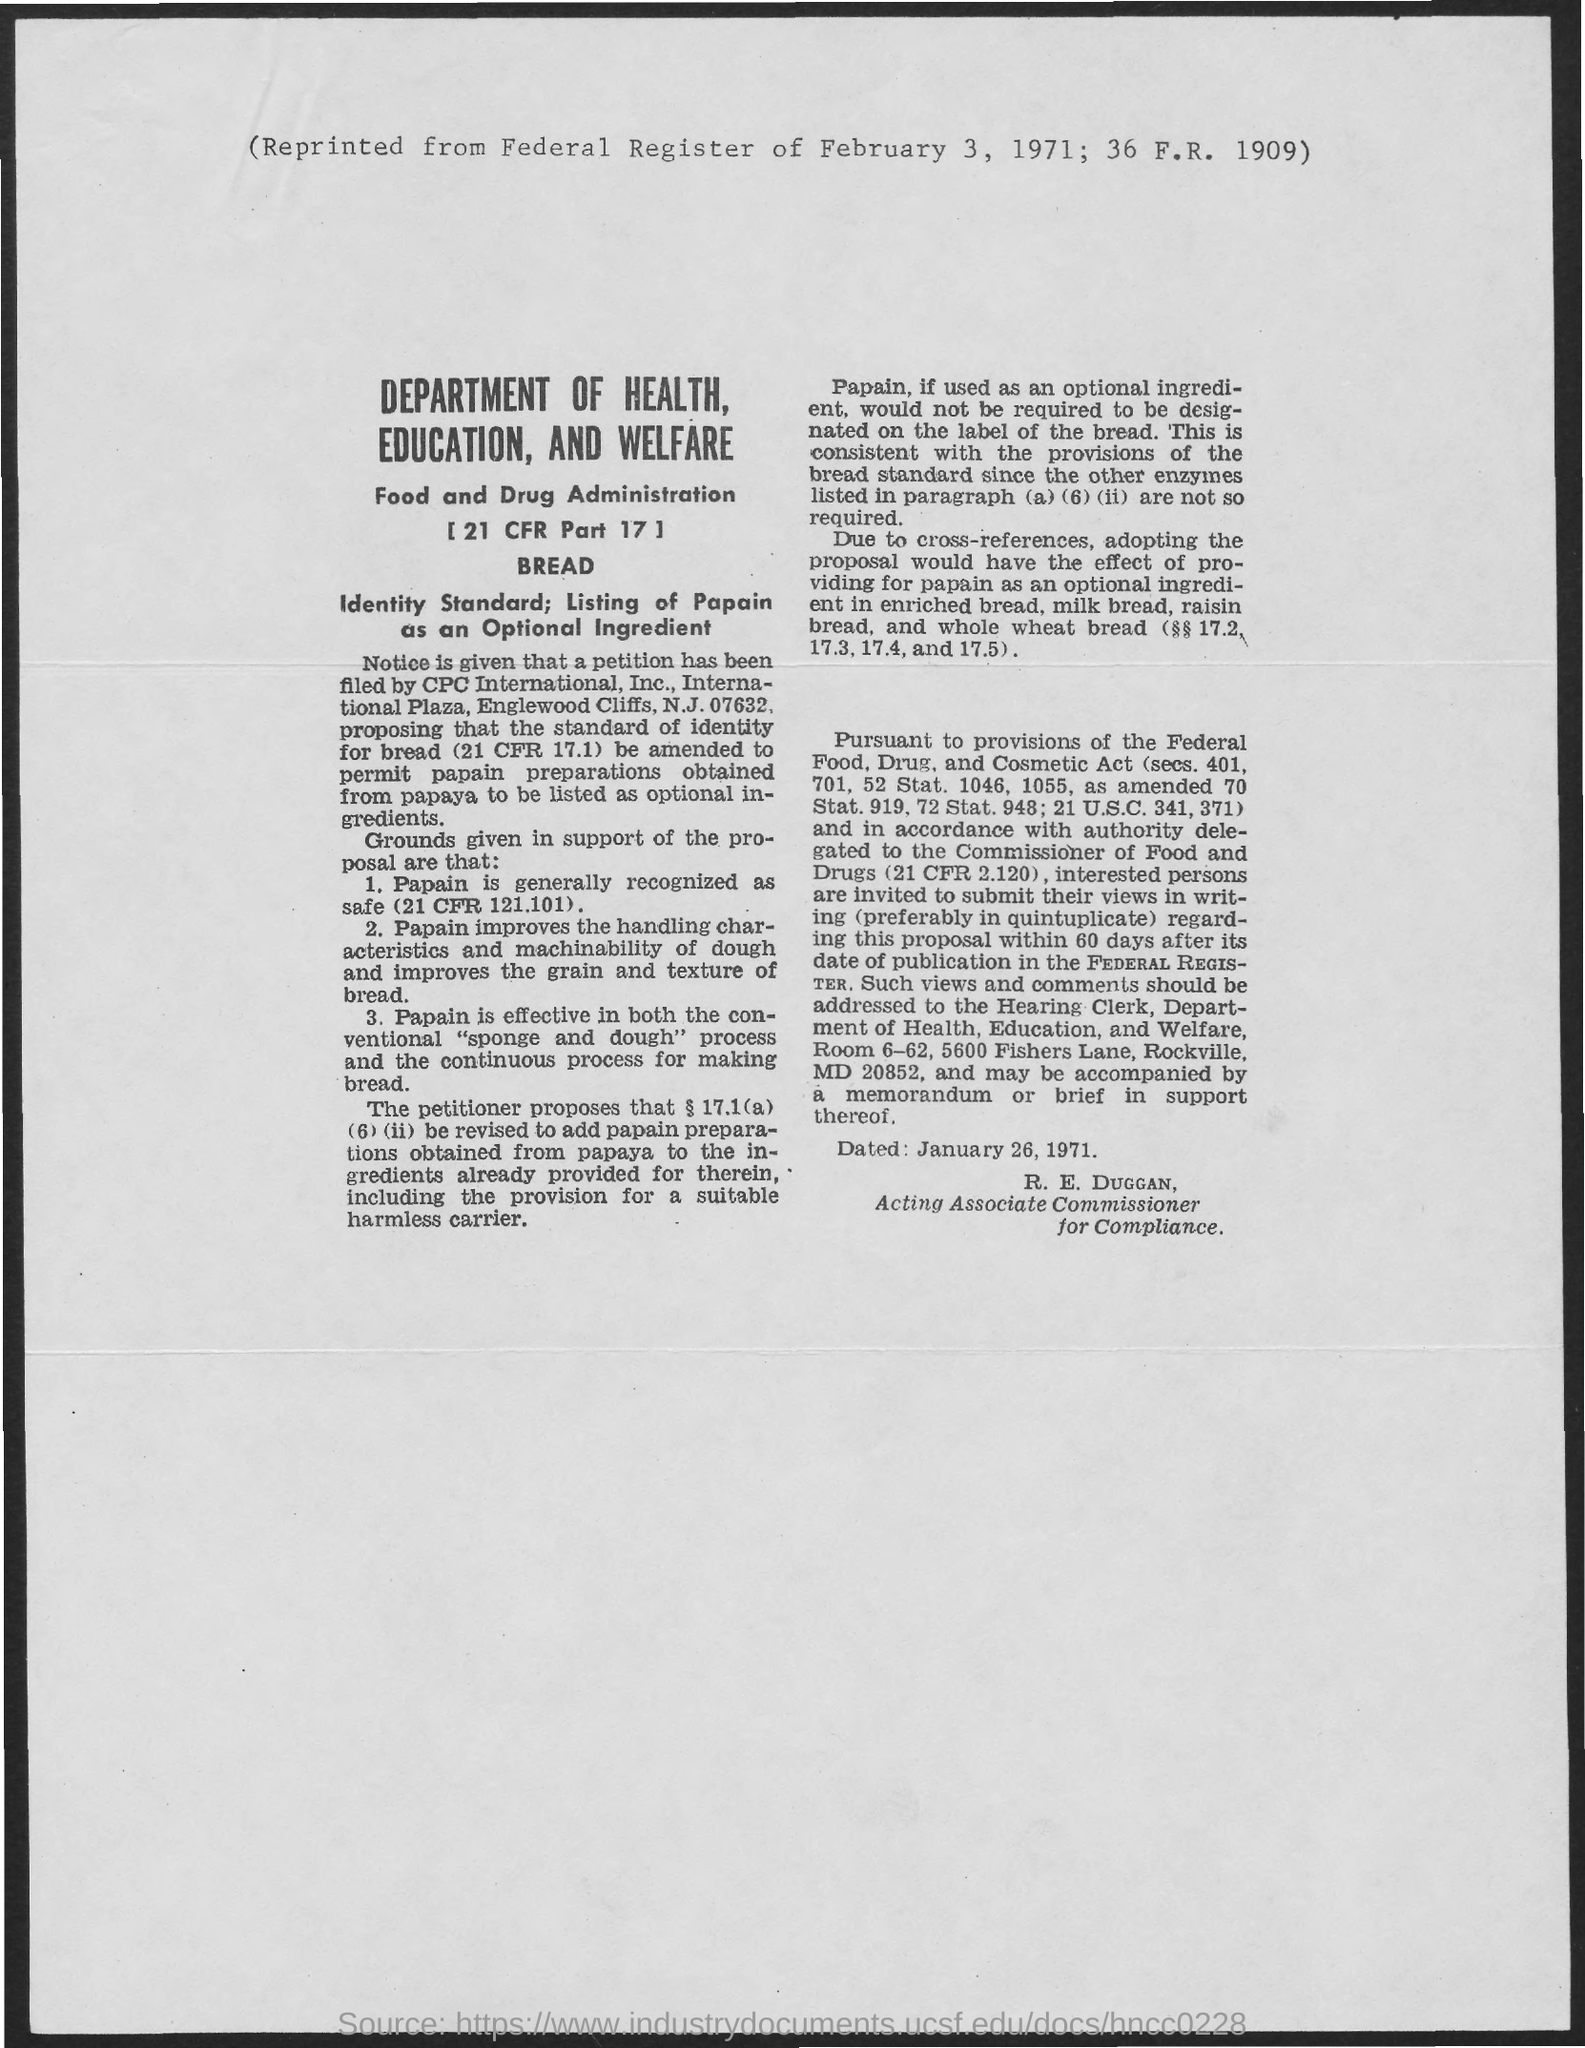When is it reprinted from federal register
Give a very brief answer. February 3 , 1971. When is it dated ?
Your answer should be very brief. January 26, 1971. 